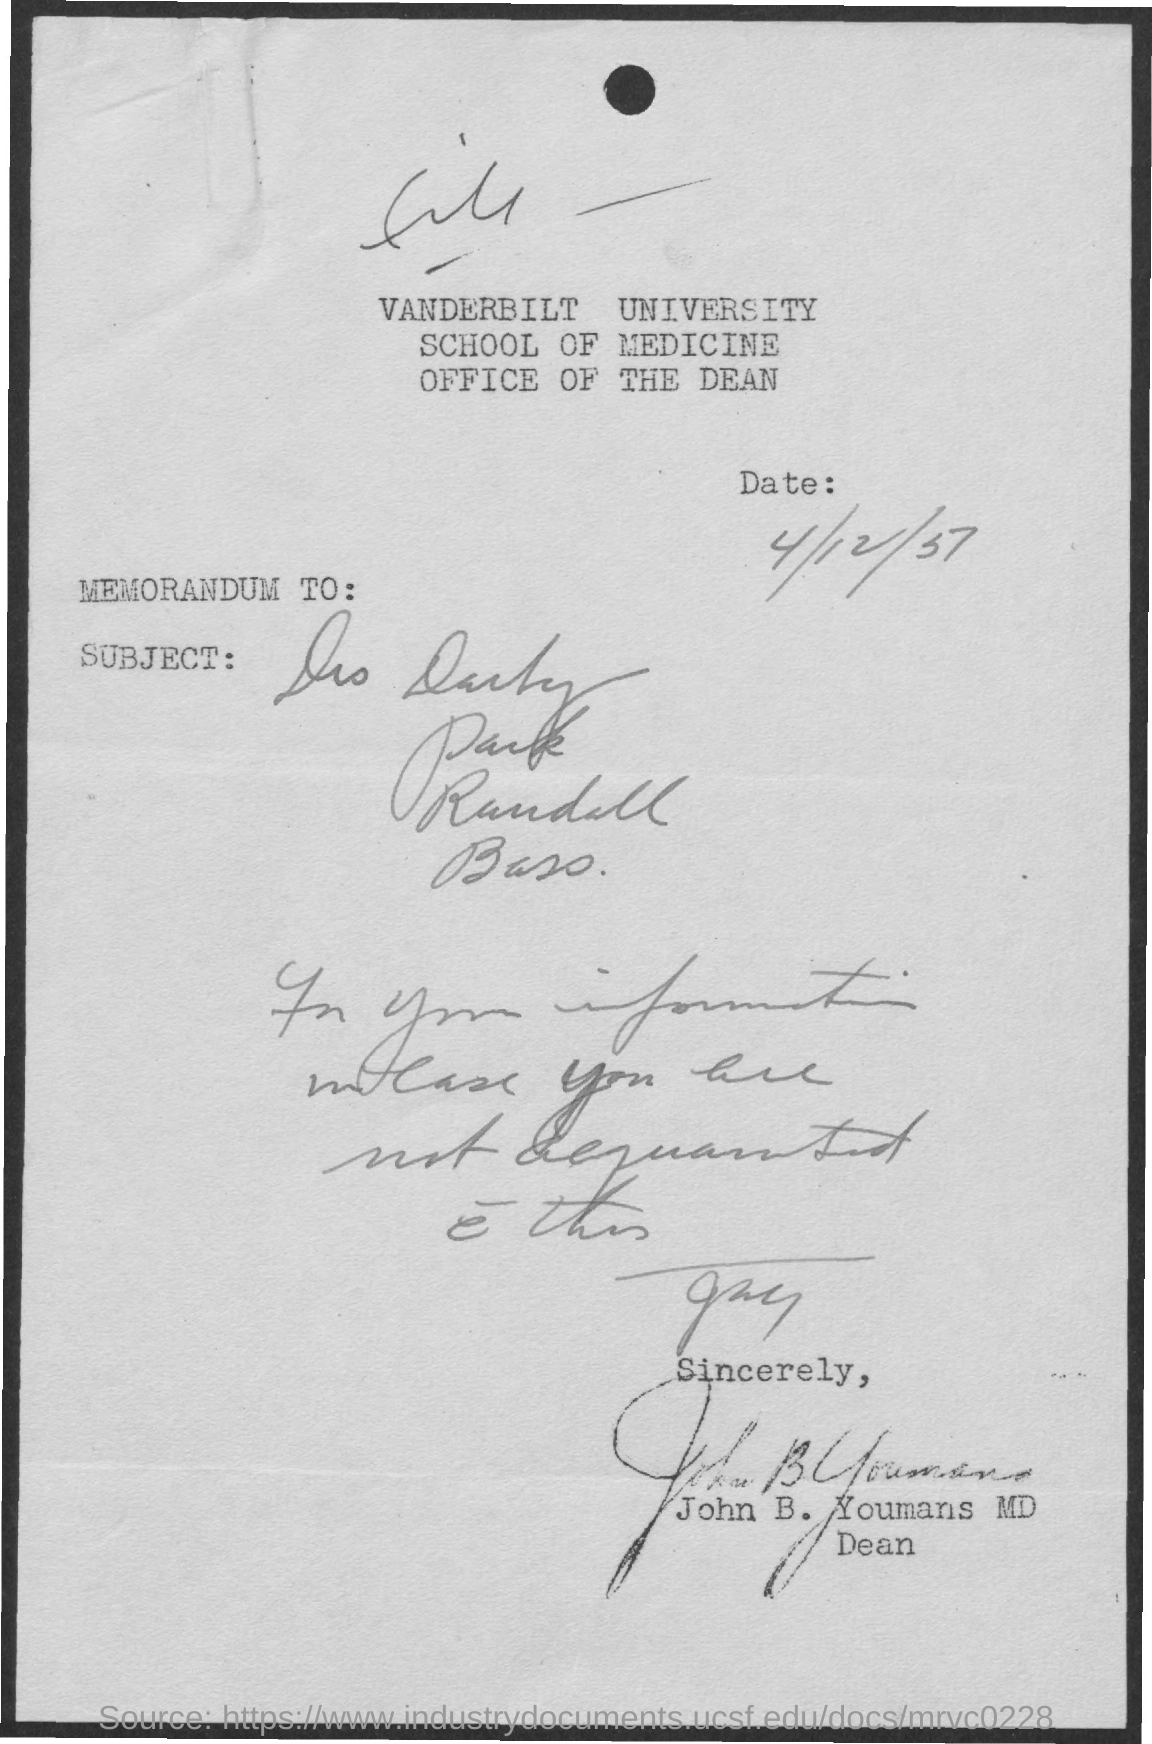Outline some significant characteristics in this image. Vanderbilt University is the name of the university. 